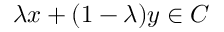Convert formula to latex. <formula><loc_0><loc_0><loc_500><loc_500>\lambda x + ( 1 - \lambda ) y \in C</formula> 